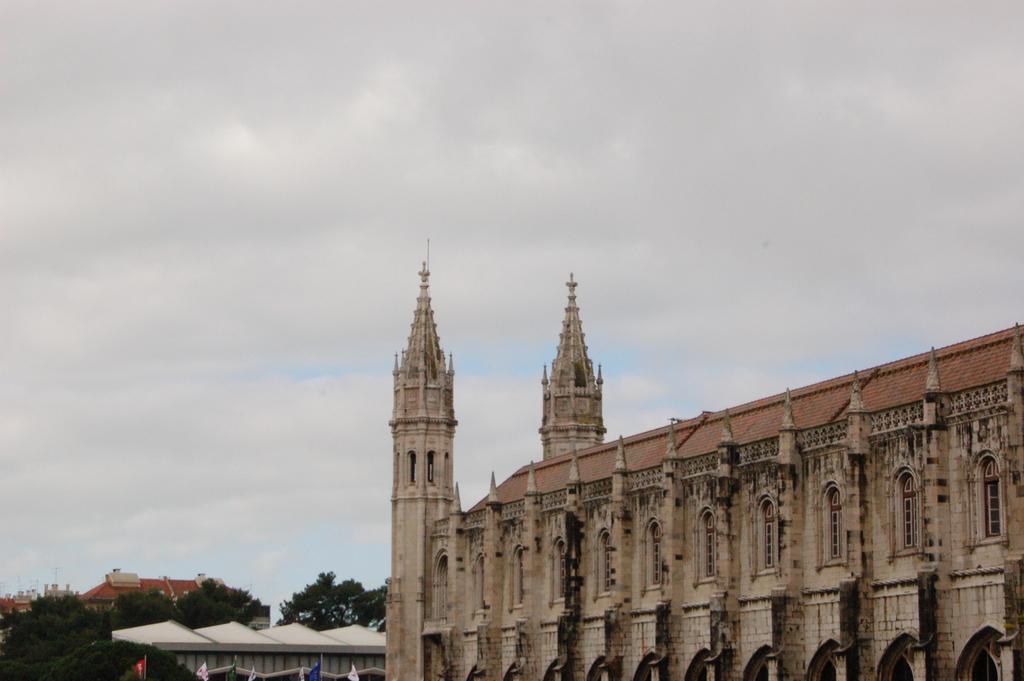Please provide a concise description of this image. In this image I can see on the right side there is a building. On the left side there are trees, at the top it is the cloudy sky. 